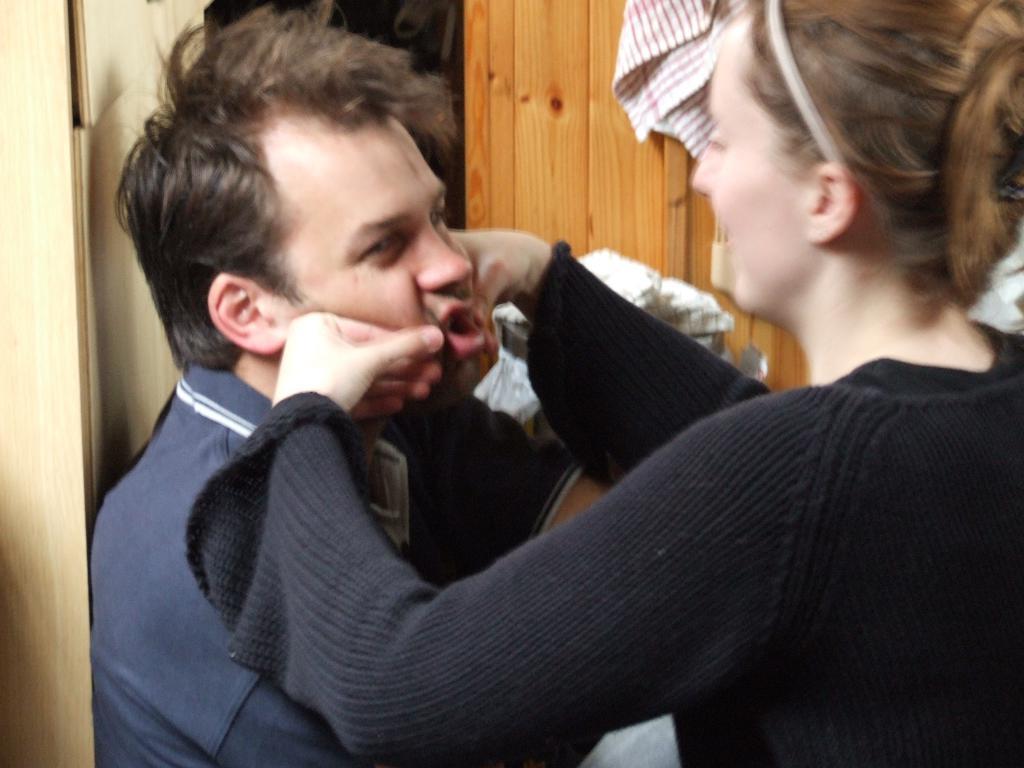Could you give a brief overview of what you see in this image? In this image we can see a man and a woman. In the background, we can see clothes and a wooden object. 